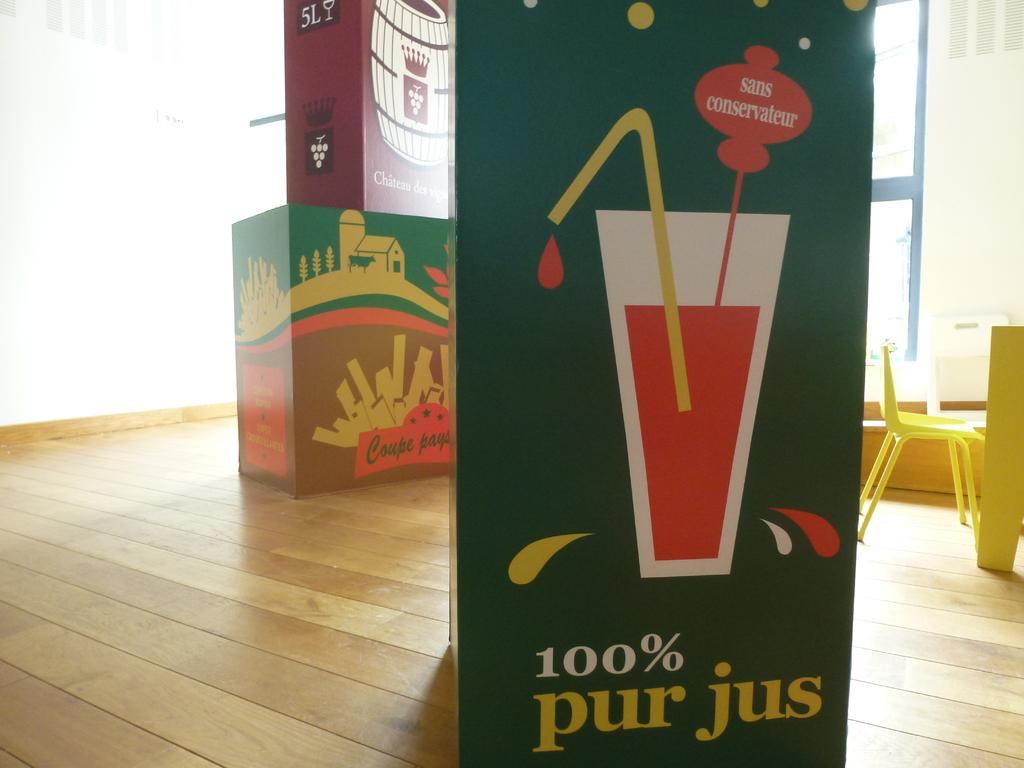What objects are on the floor in the image? There are card boxes on the floor. What can be seen on the left side of the image? There is a wall on the left side of the image. What is located on the right side of the image? There is a table and a chair on the right side of the image. What type of bait is being used to catch fish in the image? There is no mention of fish or bait in the image; it only features card boxes, a wall, a table, and a chair. 